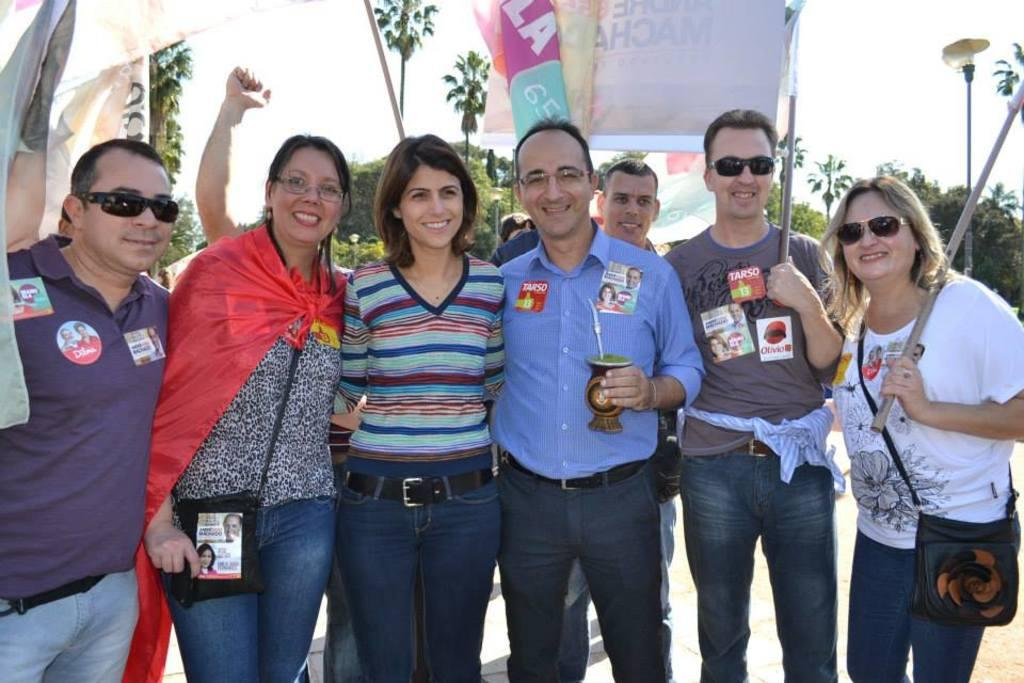What is happening in the image involving a group of people? There is a group of people in the image, and they are standing. How are the people in the image feeling or expressing themselves? The people in the image are smiling. What else can be seen in the image besides the group of people? There are banners and trees in the image. What is visible in the background of the image? The sky is visible in the background of the image. How many kittens are sitting on the people's chins in the image? There are no kittens or chins visible in the image; it features a group of people standing with banners and trees in the background. 